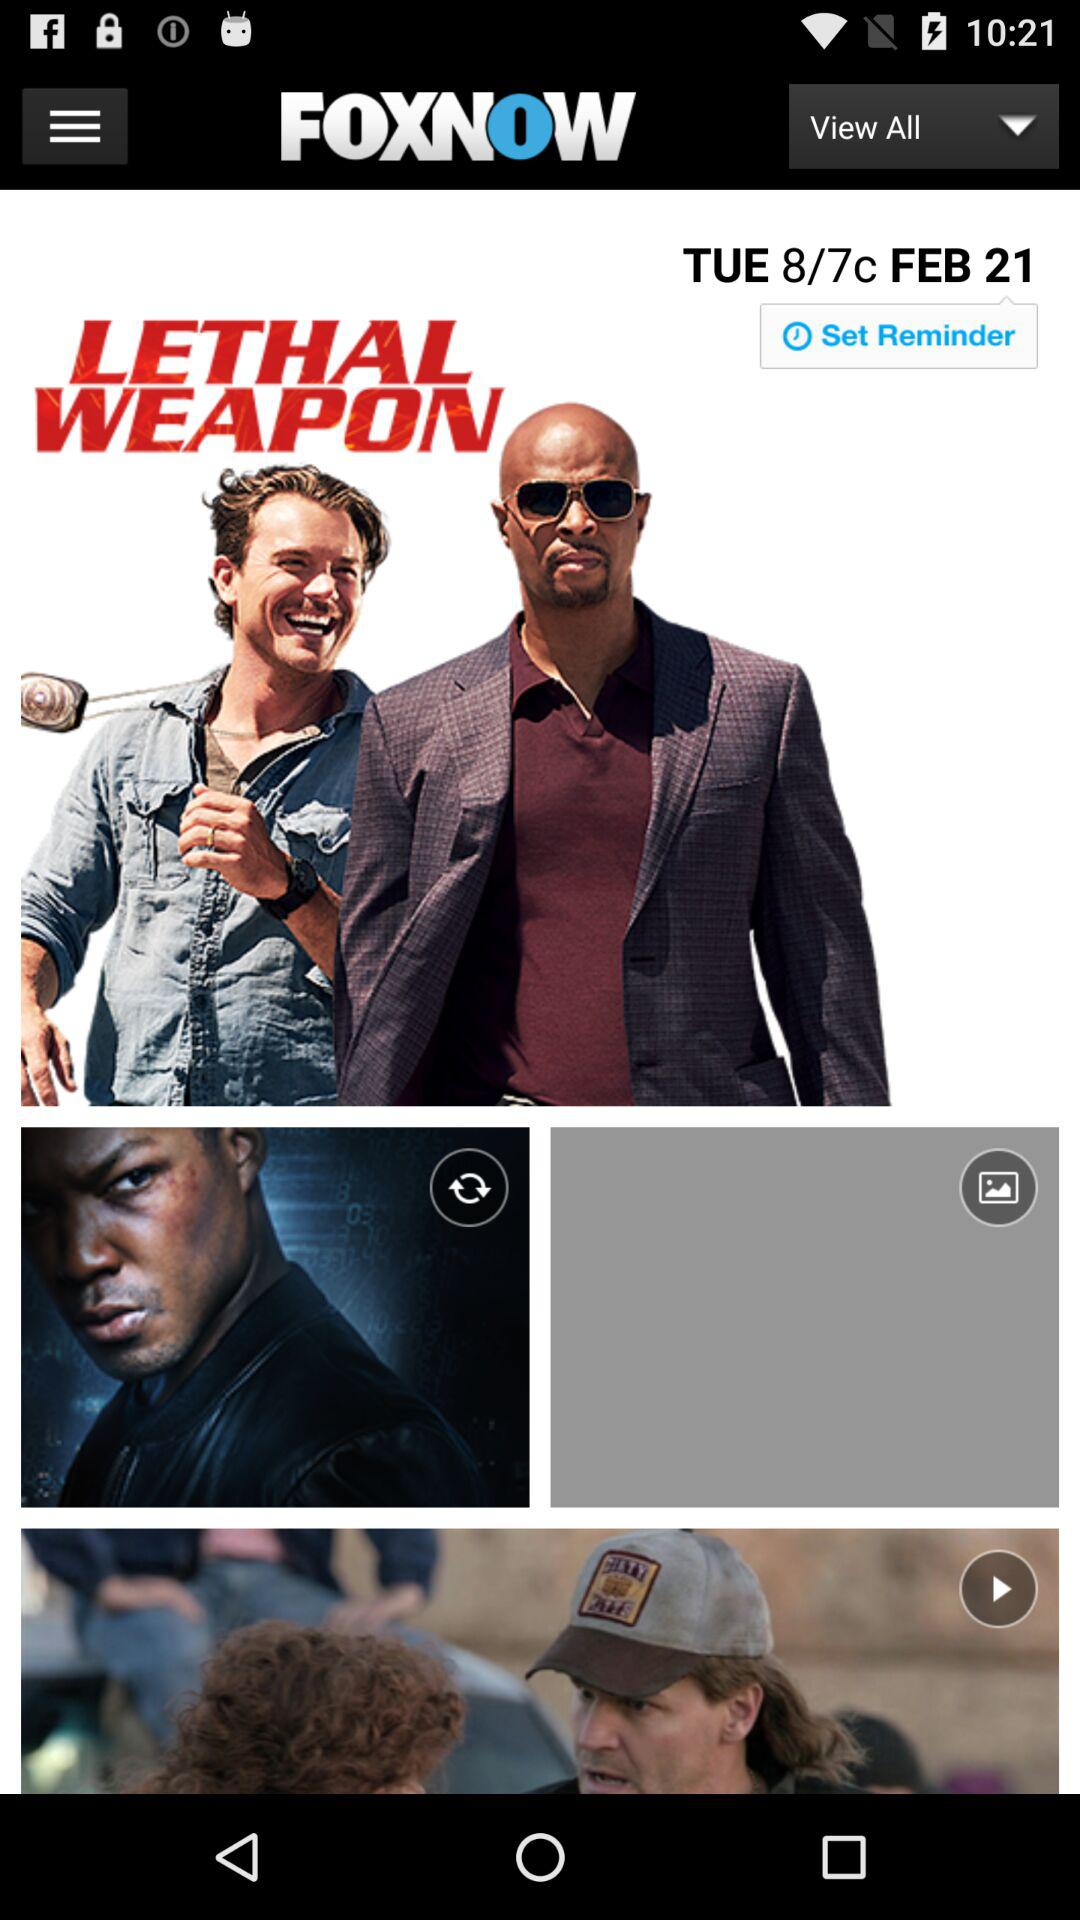Which date is selected for the reminder? The selected date is Tuesday, February 21. 